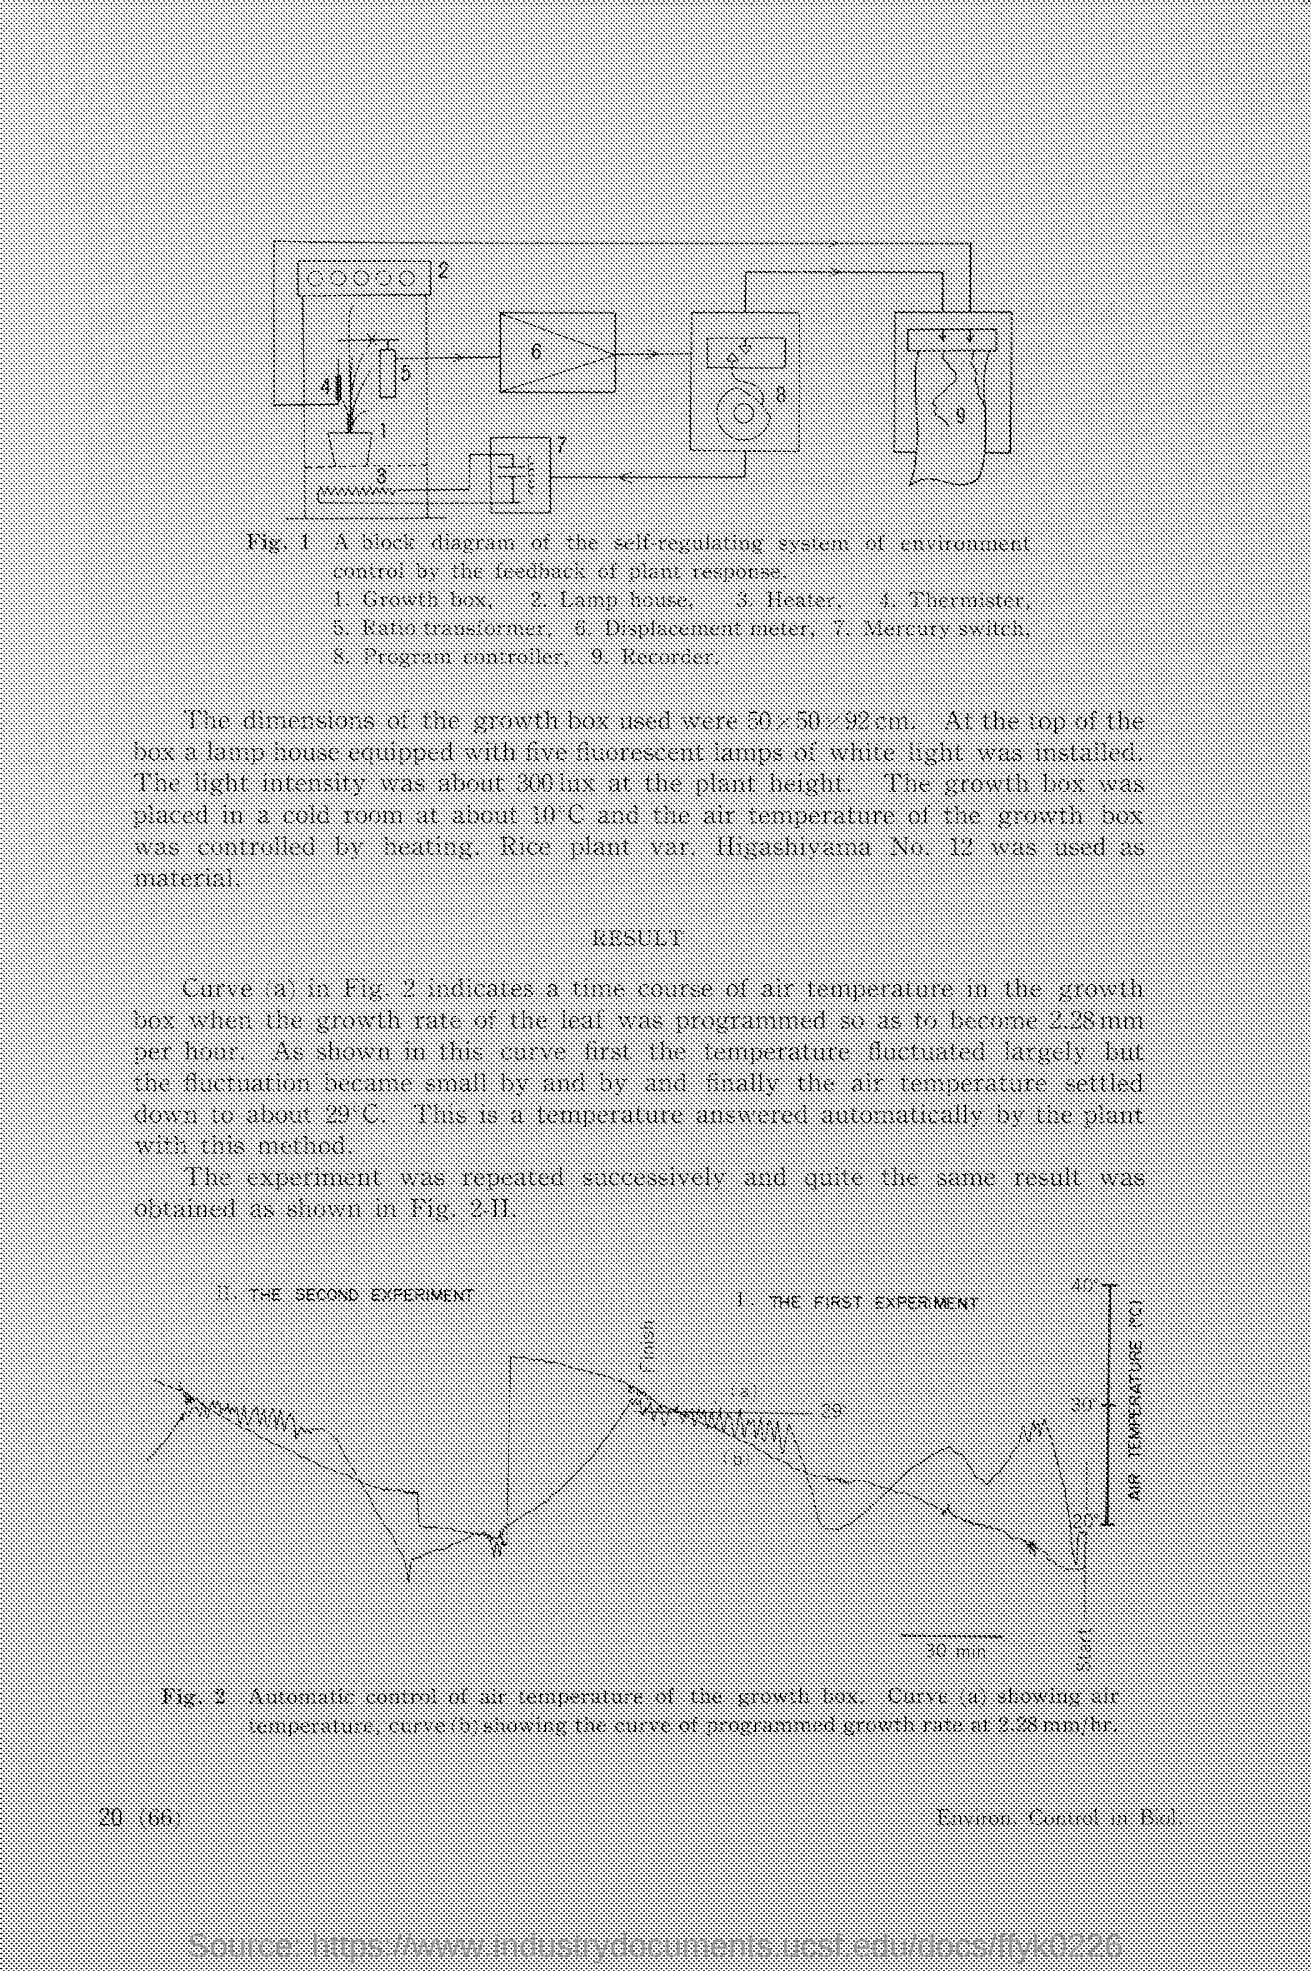Identify some key points in this picture. The growth box was placed in a cold room. The lamp house is equipped with five fluorescent lamps. 